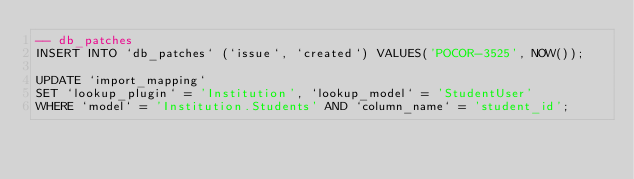Convert code to text. <code><loc_0><loc_0><loc_500><loc_500><_SQL_>-- db_patches
INSERT INTO `db_patches` (`issue`, `created`) VALUES('POCOR-3525', NOW());

UPDATE `import_mapping`
SET `lookup_plugin` = 'Institution', `lookup_model` = 'StudentUser'
WHERE `model` = 'Institution.Students' AND `column_name` = 'student_id';
</code> 